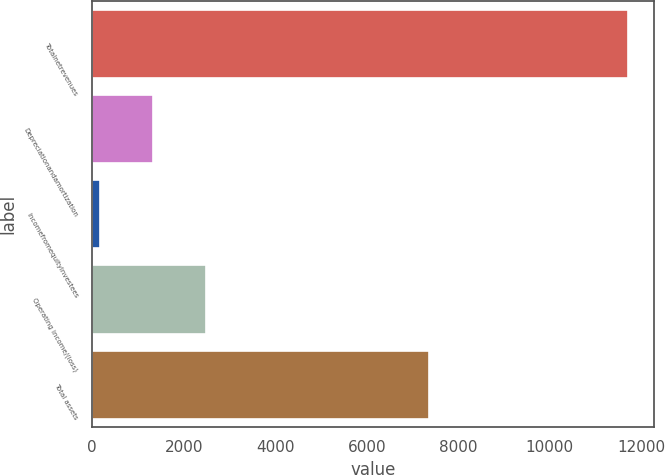Convert chart. <chart><loc_0><loc_0><loc_500><loc_500><bar_chart><fcel>Totalnetrevenues<fcel>Depreciationandamortization<fcel>Incomefromequityinvestees<fcel>Operating income/(loss)<fcel>Total assets<nl><fcel>11700.4<fcel>1326.37<fcel>173.7<fcel>2479.04<fcel>7360.4<nl></chart> 